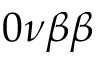<formula> <loc_0><loc_0><loc_500><loc_500>0 \nu \beta \beta</formula> 